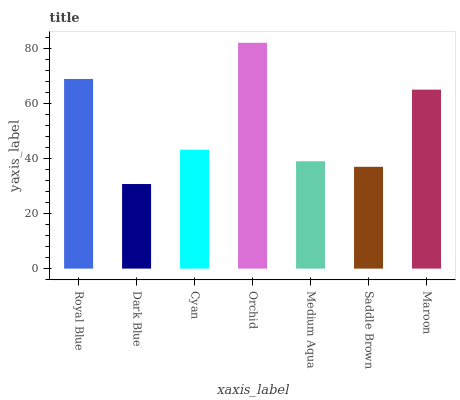Is Dark Blue the minimum?
Answer yes or no. Yes. Is Orchid the maximum?
Answer yes or no. Yes. Is Cyan the minimum?
Answer yes or no. No. Is Cyan the maximum?
Answer yes or no. No. Is Cyan greater than Dark Blue?
Answer yes or no. Yes. Is Dark Blue less than Cyan?
Answer yes or no. Yes. Is Dark Blue greater than Cyan?
Answer yes or no. No. Is Cyan less than Dark Blue?
Answer yes or no. No. Is Cyan the high median?
Answer yes or no. Yes. Is Cyan the low median?
Answer yes or no. Yes. Is Dark Blue the high median?
Answer yes or no. No. Is Royal Blue the low median?
Answer yes or no. No. 